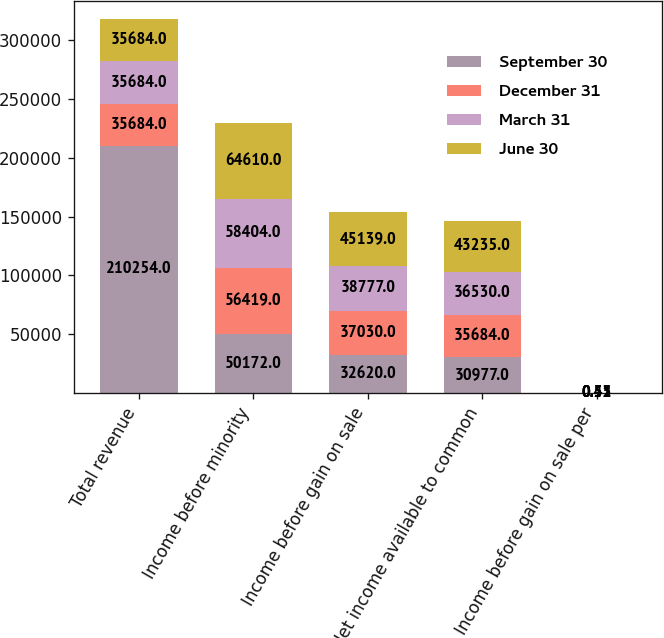Convert chart. <chart><loc_0><loc_0><loc_500><loc_500><stacked_bar_chart><ecel><fcel>Total revenue<fcel>Income before minority<fcel>Income before gain on sale<fcel>Net income available to common<fcel>Income before gain on sale per<nl><fcel>September 30<fcel>210254<fcel>50172<fcel>32620<fcel>30977<fcel>0.45<nl><fcel>December 31<fcel>35684<fcel>56419<fcel>37030<fcel>35684<fcel>0.51<nl><fcel>March 31<fcel>35684<fcel>58404<fcel>38777<fcel>36530<fcel>0.53<nl><fcel>June 30<fcel>35684<fcel>64610<fcel>45139<fcel>43235<fcel>0.52<nl></chart> 